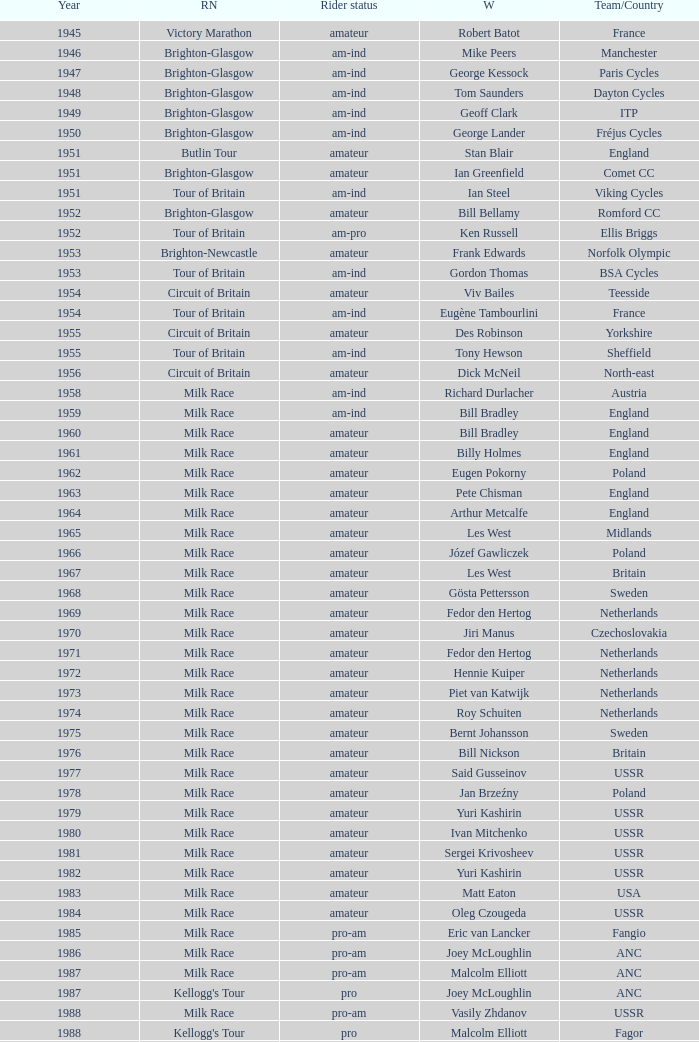What is the rider status for the 1971 netherlands team? Amateur. 